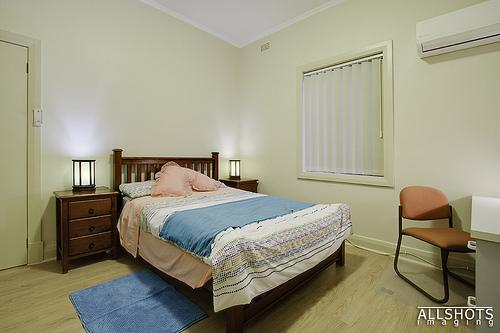Create a brief description of the bedding materials on the cot in the image. The cot has a pink pillow, a light blue sheet, and a multicolored striped blanket. What type of object is placed in the corner of the room, and what color is it? A brown wooden desk is placed in the corner of the room. List the colors and objects that can be found on the floor of the room. A blue floor mat is present on the floor. Identify the primary furniture piece in the image and describe its features. The primary furniture piece is a wooden cot with a mattress, featuring a brown wooden bed frame and a pink pillow on the bed. 